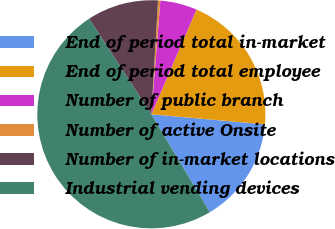<chart> <loc_0><loc_0><loc_500><loc_500><pie_chart><fcel>End of period total in-market<fcel>End of period total employee<fcel>Number of public branch<fcel>Number of active Onsite<fcel>Number of in-market locations<fcel>Industrial vending devices<nl><fcel>15.03%<fcel>19.94%<fcel>5.22%<fcel>0.32%<fcel>10.13%<fcel>49.37%<nl></chart> 